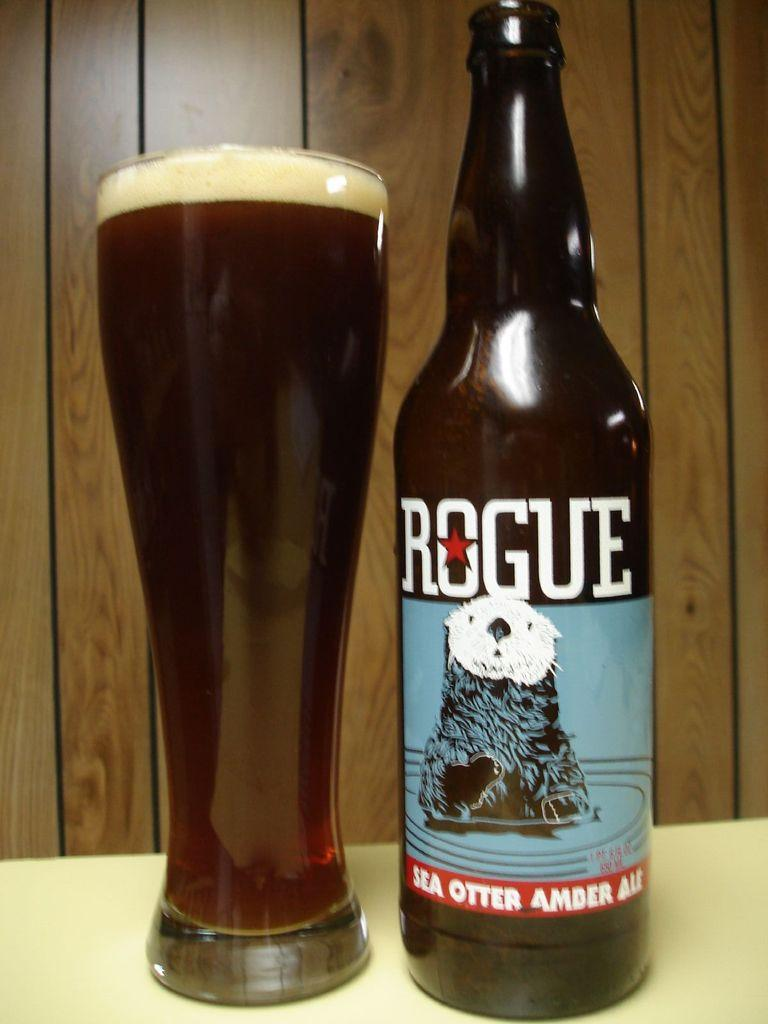<image>
Describe the image concisely. the word rogue that is on a beer bottle 